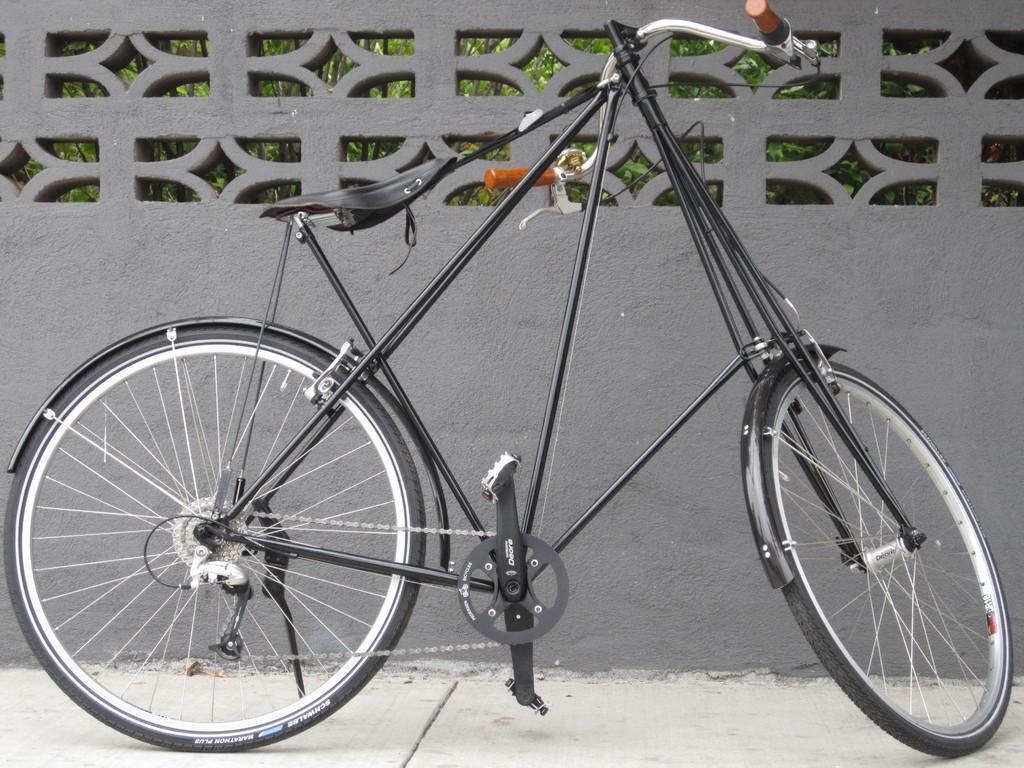Could you give a brief overview of what you see in this image? In the center of the image there is a bicycle. In the background there is a wall. 